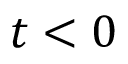Convert formula to latex. <formula><loc_0><loc_0><loc_500><loc_500>t < 0</formula> 